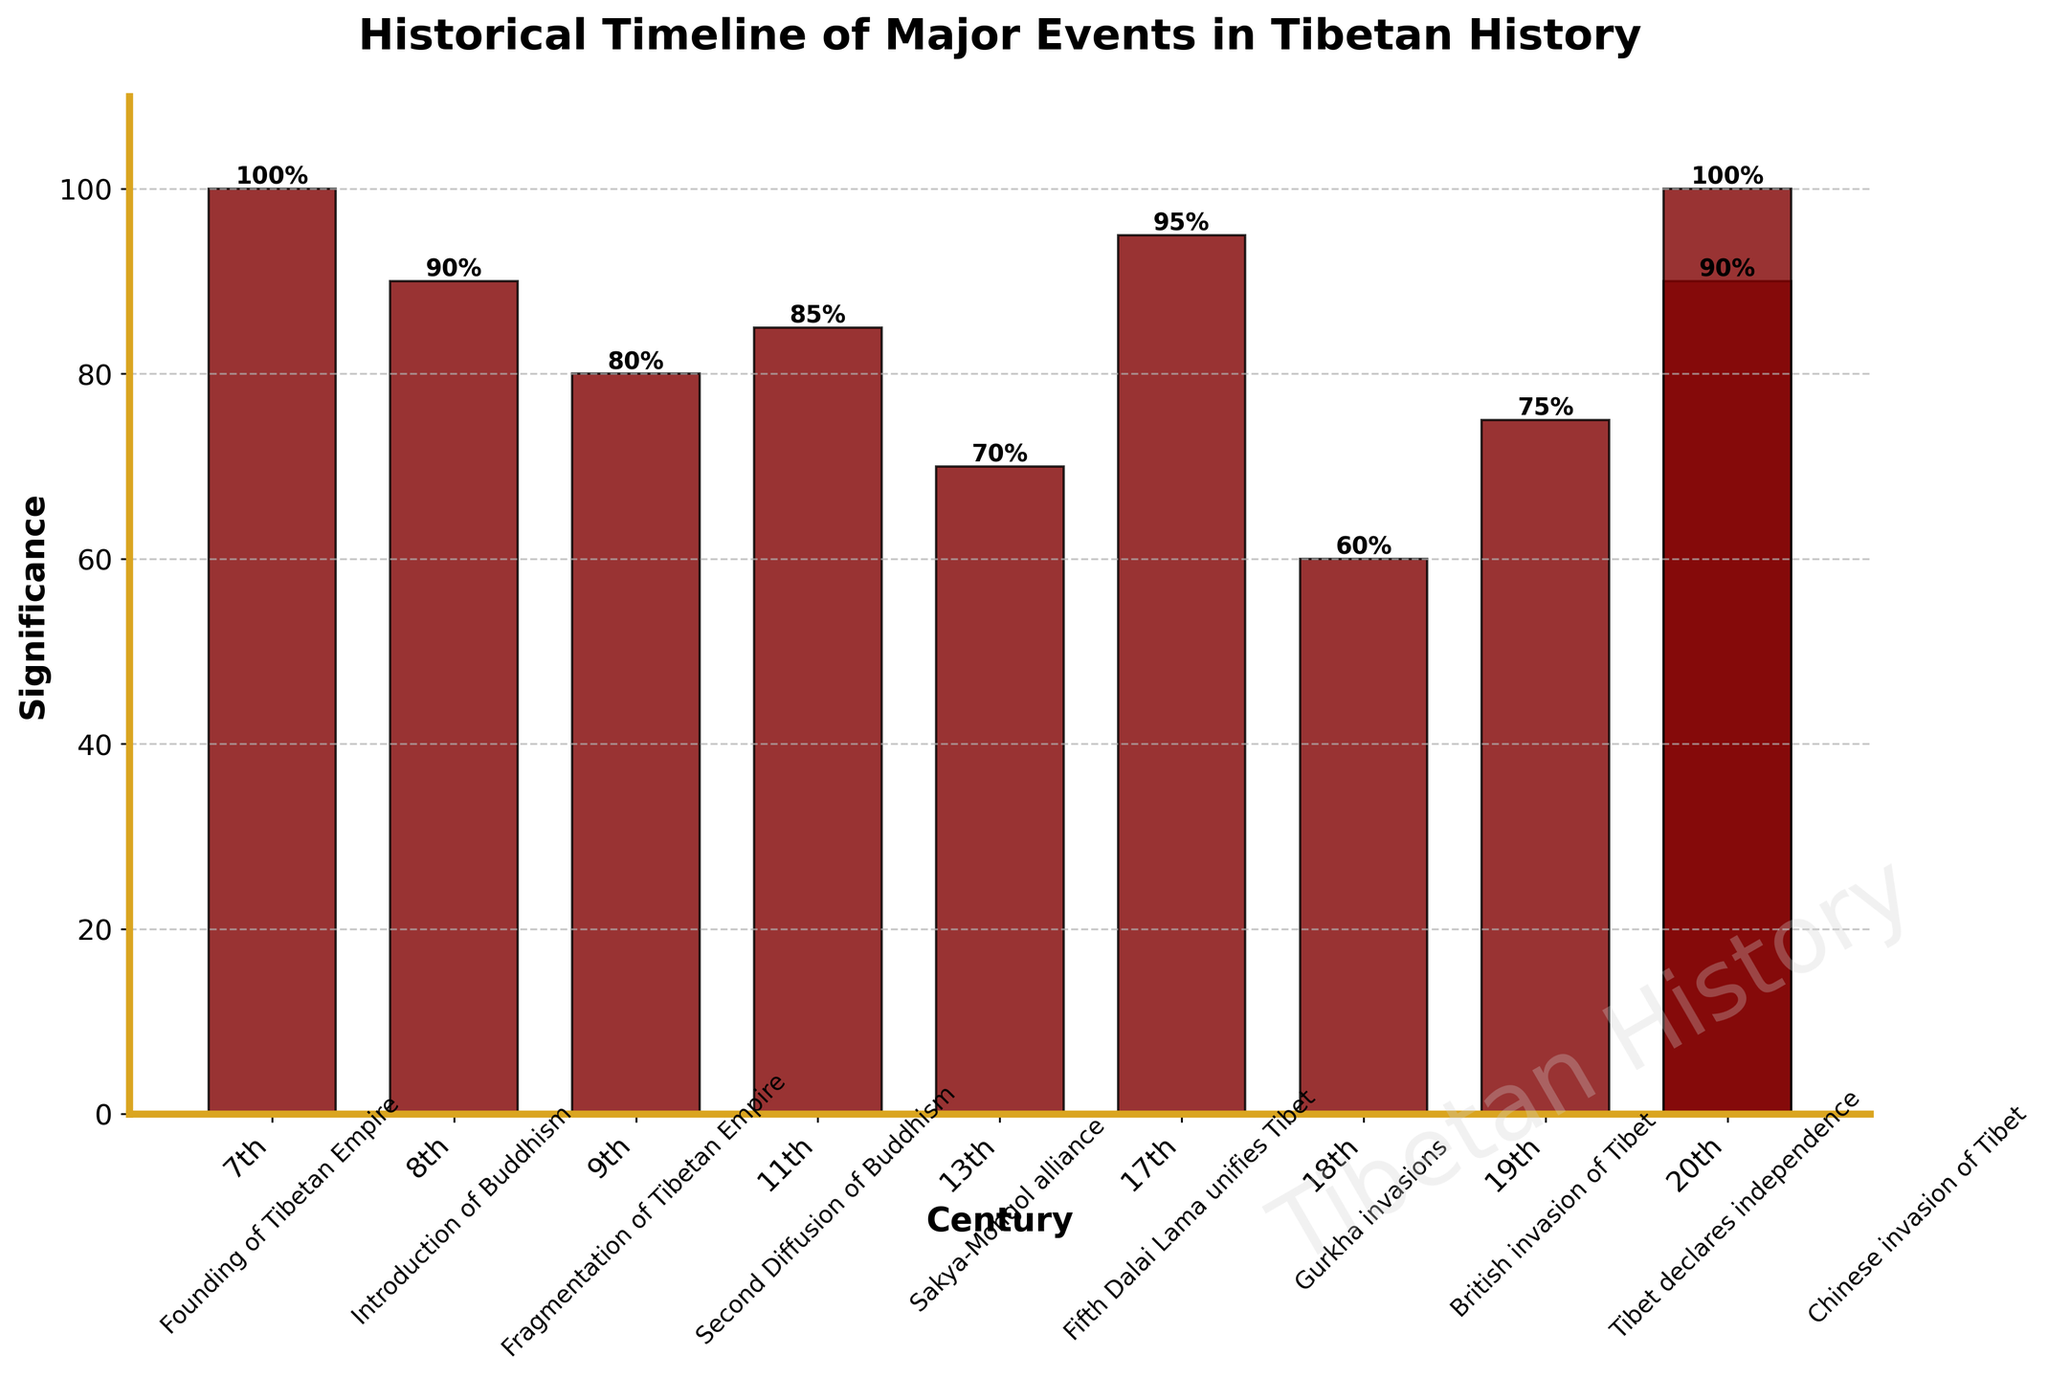what is the title of the plot? The title of the plot can be found at the top of the figure, which states the main subject illustrated.
Answer: Historical Timeline of Major Events in Tibetan History Which century has the event with the highest significance? Locate the tallest bar in the bar chart and check its x-axis label to find out the associated century.
Answer: 7th Century and 20th Century What is the significance value for the British invasion of Tibet? Identify the event labeled "British invasion of Tibet" below the x-axis and then read the corresponding bar height to determine its significance value.
Answer: 75 Which century experienced the introduction of Buddhism? By examining the event labels below the x-axis, find "Introduction of Buddhism" and identify the century directly above it.
Answer: 8th Century Compared to the British invasion of Tibet, how much more significant is the event, "Tibet declares independence"? Determine the significance values of both events from their corresponding bar heights, then subtract the value for the British invasion of Tibet from that of Tibet declaring independence.
Answer: 15 How many events listed have a significance value of 90 or higher? Count the number of bars that reach or exceed the significance value line marked at 90 on the y-axis.
Answer: 4 Which event in the 11th century has a significance value? Locate the century labeled "11th" on the x-axis and identify the event listed below that corresponds to this century.
Answer: Second Diffusion of Buddhism What is the average significance value of events in the 20th century? Identify the significance values of both events in the 20th century, sum them up, and then divide by 2 to find the average. (90 + 100) / 2 = 95
Answer: 95 Which century has the lowest significance event? Find the shortest bar in the bar chart and identify the corresponding century from the x-axis label of this bar.
Answer: 18th Century Is the introduction of Buddhism more significant than the Sakya-Mongol alliance? Compare the heights of the bars corresponding to the "Introduction of Buddhism" and "Sakya-Mongol alliance" events to ascertain which is taller.
Answer: Yes 